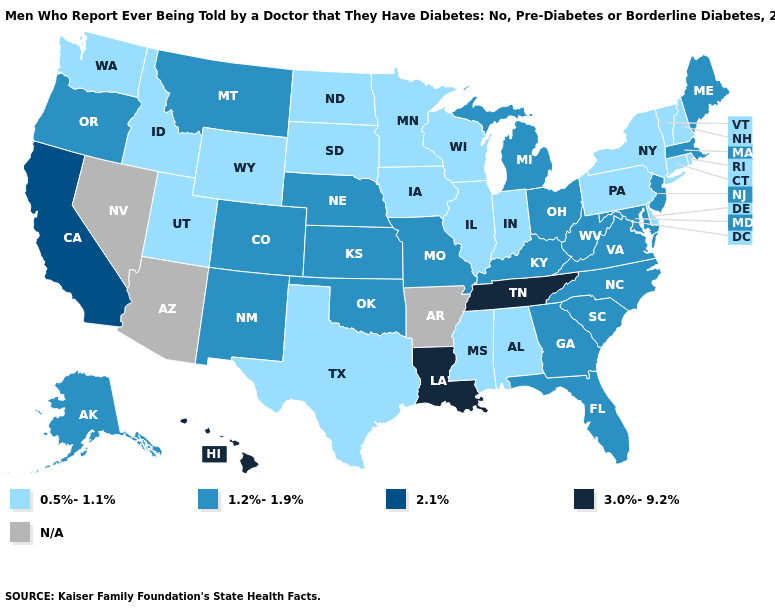What is the highest value in the Northeast ?
Quick response, please. 1.2%-1.9%. Is the legend a continuous bar?
Concise answer only. No. Does Vermont have the lowest value in the USA?
Keep it brief. Yes. What is the highest value in states that border Texas?
Give a very brief answer. 3.0%-9.2%. Name the states that have a value in the range 3.0%-9.2%?
Write a very short answer. Hawaii, Louisiana, Tennessee. What is the value of Tennessee?
Short answer required. 3.0%-9.2%. What is the highest value in states that border Maine?
Short answer required. 0.5%-1.1%. What is the highest value in states that border Arkansas?
Keep it brief. 3.0%-9.2%. What is the value of Alaska?
Write a very short answer. 1.2%-1.9%. What is the highest value in the MidWest ?
Keep it brief. 1.2%-1.9%. What is the highest value in states that border Alabama?
Give a very brief answer. 3.0%-9.2%. What is the value of West Virginia?
Keep it brief. 1.2%-1.9%. Among the states that border Maine , which have the lowest value?
Short answer required. New Hampshire. Name the states that have a value in the range 3.0%-9.2%?
Keep it brief. Hawaii, Louisiana, Tennessee. What is the value of Wisconsin?
Keep it brief. 0.5%-1.1%. 